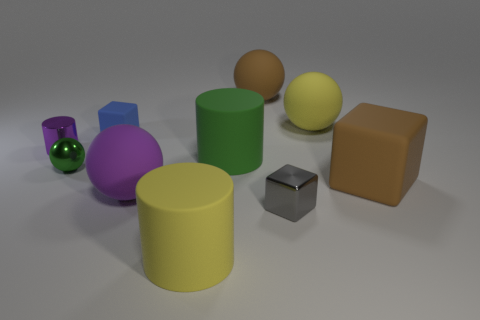Subtract all red spheres. Subtract all gray blocks. How many spheres are left? 4 Subtract all blocks. How many objects are left? 7 Subtract 1 blue cubes. How many objects are left? 9 Subtract all matte cylinders. Subtract all brown rubber spheres. How many objects are left? 7 Add 7 metal objects. How many metal objects are left? 10 Add 9 yellow spheres. How many yellow spheres exist? 10 